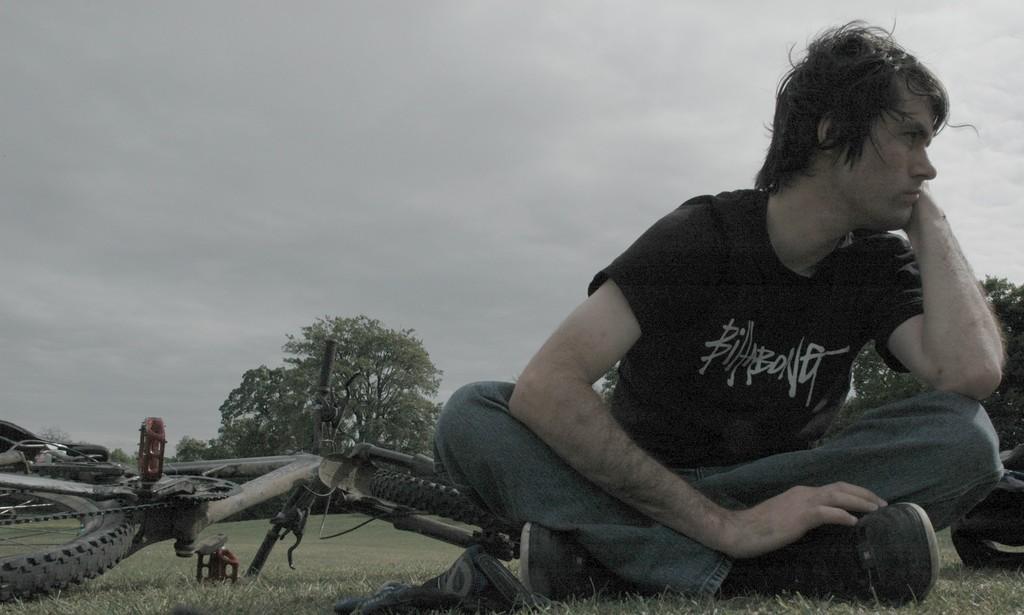In one or two sentences, can you explain what this image depicts? In this picture I can see a man sitting on the grass, there are two objects on the grass, there is a bicycle, trees, and in the background there is sky. 